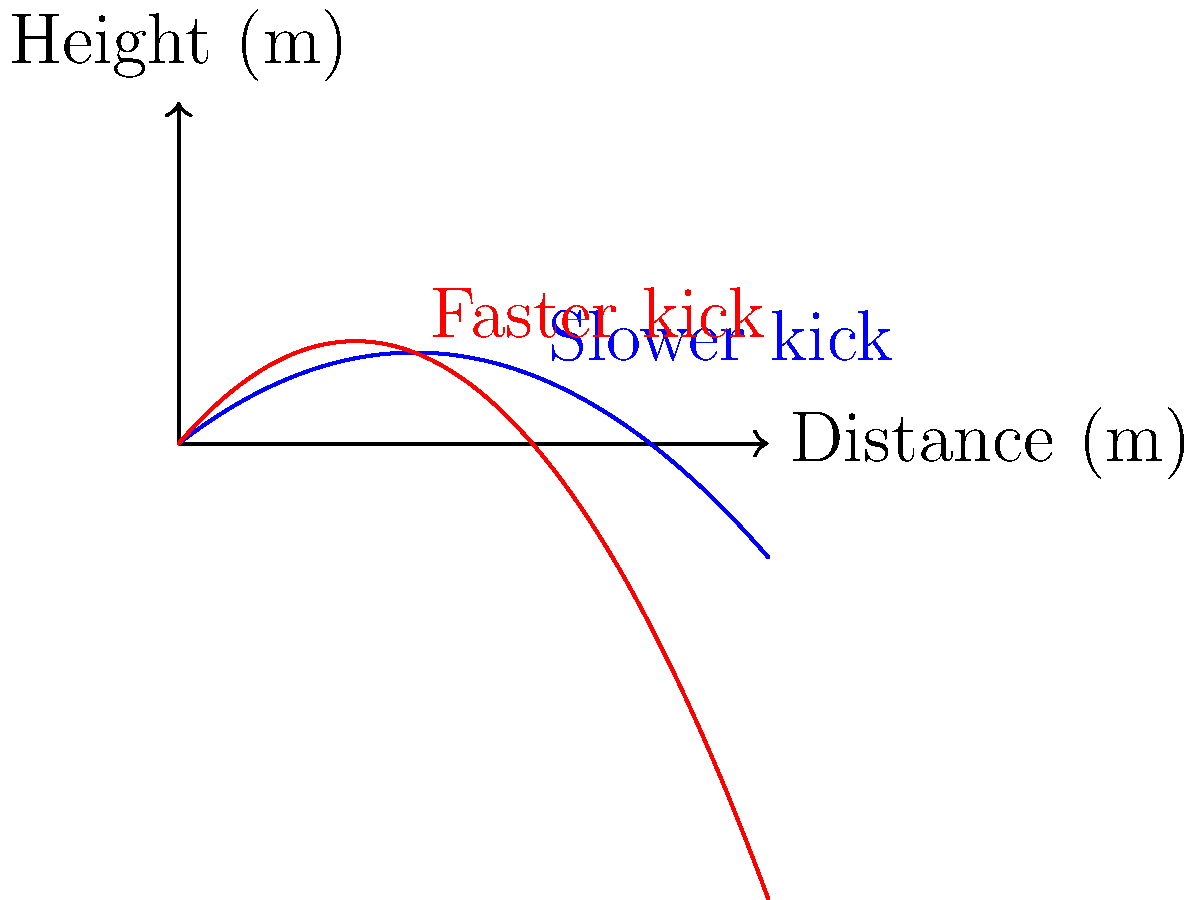The graph shows the trajectories of two soccer balls kicked with different initial velocities. Which kick results in the ball traveling a greater distance? To determine which kick results in the ball traveling a greater distance, we need to look at where each trajectory intersects the x-axis (representing the ground). This point of intersection indicates how far the ball travels before hitting the ground.

Step 1: Observe the blue curve (slower kick)
- The blue curve reaches the x-axis at about 80 meters.

Step 2: Observe the red curve (faster kick)
- The red curve reaches the x-axis at about 60 meters.

Step 3: Compare the distances
- The blue curve (slower kick) travels further before hitting the ground.

Step 4: Interpret the results
- Even though the red curve (faster kick) reaches a higher maximum height, it doesn't travel as far horizontally.
- The slower kick has a more gradual arc, allowing the ball to stay in the air longer and travel a greater distance.

Therefore, the slower kick (represented by the blue curve) results in the ball traveling a greater distance.
Answer: The slower kick (blue curve) 